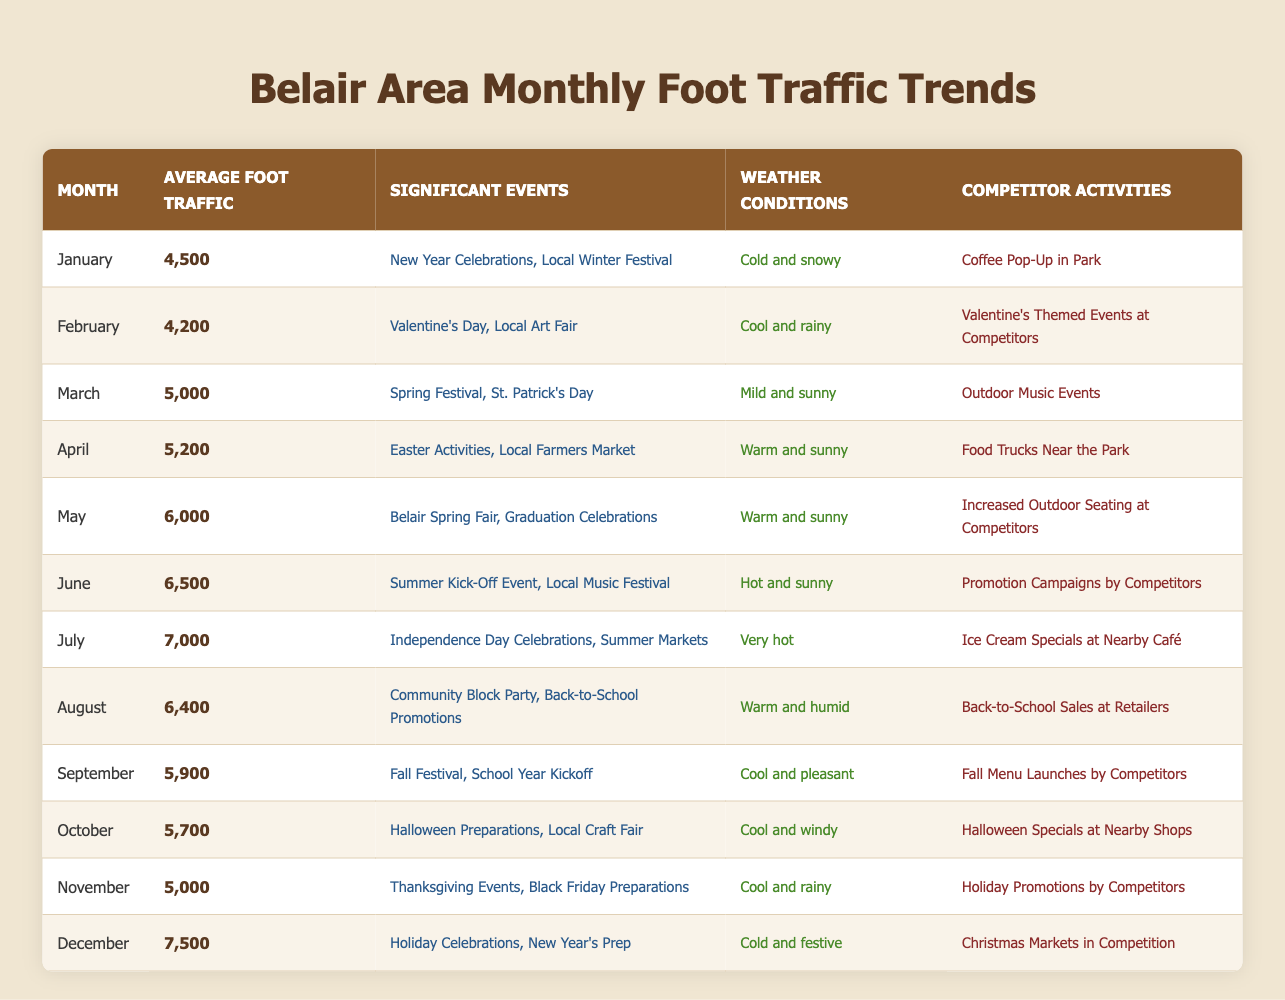What was the average foot traffic in July? According to the table, the average foot traffic for July is listed as 7,000.
Answer: 7,000 What weather conditions were prevalent in May? The table indicates that the weather conditions in May were warm and sunny.
Answer: Warm and sunny Which month had the highest foot traffic? Looking through the average foot traffic values in the table, December has the highest figure at 7,500.
Answer: December What are the significant events that occurred in June? From the table, the significant events listed for June are the Summer Kick-Off Event and the Local Music Festival.
Answer: Summer Kick-Off Event, Local Music Festival Did any month have foot traffic of less than 5,000? By checking the values in the average foot traffic column, January (4,500) and February (4,200) both had foot traffic below 5,000.
Answer: Yes What was the change in average foot traffic from May to June? The average foot traffic in May is 6,000, and in June it is 6,500. The difference is calculated by subtracting May's value from June's: 6,500 - 6,000 = 500.
Answer: 500 How does the average foot traffic in October compare to that in December? The average foot traffic for October is 5,700 and for December is 7,500. The difference can be found by subtracting October's value from December: 7,500 - 5,700 = 1,800. This indicates December has much higher foot traffic than October.
Answer: 1,800 Was there any month with a community event that also had very low foot traffic? The table shows that the month with a community event, specifically November (Thanksgiving Events), had an average foot traffic of 5,000, which is relatively low compared to other months, but not the lowest.
Answer: Yes Which month had lower average foot traffic: February or March? The average foot traffic in February is 4,200 and in March it is 5,000. Since 4,200 is lower than 5,000, February had lower average foot traffic.
Answer: February 